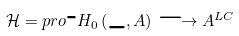Convert formula to latex. <formula><loc_0><loc_0><loc_500><loc_500>\mathcal { H } = p r o \text {-} H _ { 0 } \left ( \_ , A \right ) \longrightarrow A ^ { L C }</formula> 